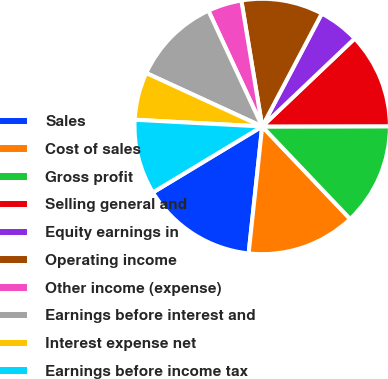<chart> <loc_0><loc_0><loc_500><loc_500><pie_chart><fcel>Sales<fcel>Cost of sales<fcel>Gross profit<fcel>Selling general and<fcel>Equity earnings in<fcel>Operating income<fcel>Other income (expense)<fcel>Earnings before interest and<fcel>Interest expense net<fcel>Earnings before income tax<nl><fcel>14.66%<fcel>13.79%<fcel>12.93%<fcel>12.07%<fcel>5.17%<fcel>10.34%<fcel>4.31%<fcel>11.21%<fcel>6.03%<fcel>9.48%<nl></chart> 